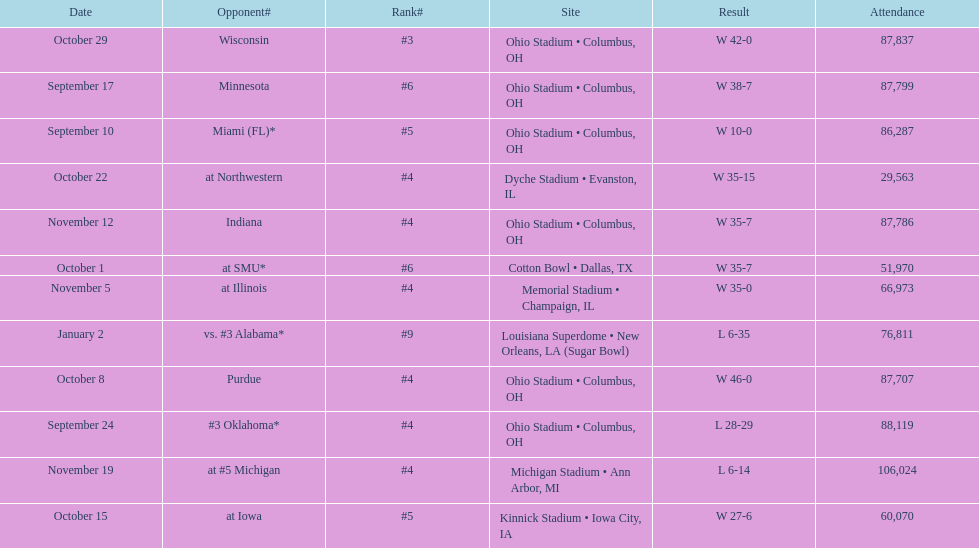What was the last game to be attended by fewer than 30,000 people? October 22. 